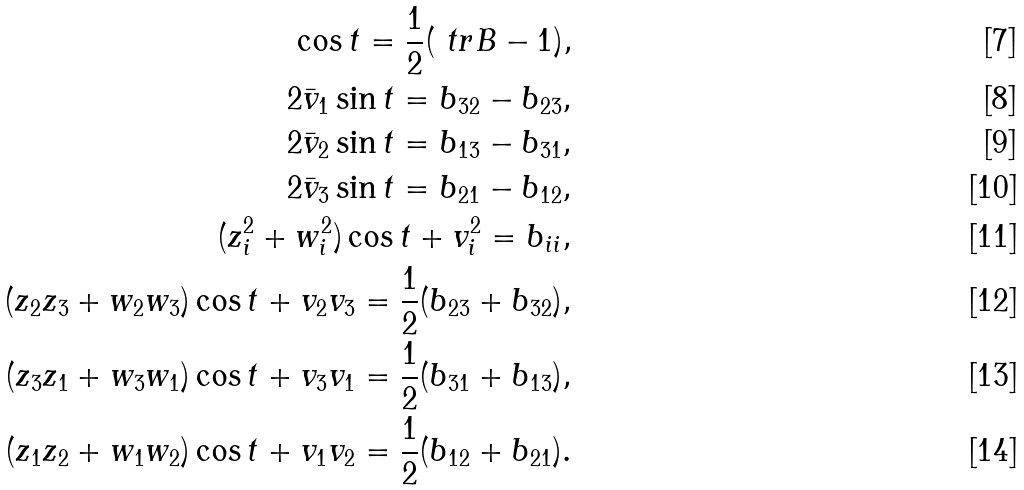<formula> <loc_0><loc_0><loc_500><loc_500>\cos t = \frac { 1 } { 2 } ( \ t r B - 1 ) , \\ 2 \bar { v } _ { 1 } \sin t = b _ { 3 2 } - b _ { 2 3 } , \\ 2 \bar { v } _ { 2 } \sin t = b _ { 1 3 } - b _ { 3 1 } , \\ 2 \bar { v } _ { 3 } \sin t = b _ { 2 1 } - b _ { 1 2 } , \\ ( z _ { i } ^ { 2 } + w _ { i } ^ { 2 } ) \cos t + v _ { i } ^ { 2 } = b _ { i i } , \\ ( z _ { 2 } z _ { 3 } + w _ { 2 } w _ { 3 } ) \cos t + v _ { 2 } v _ { 3 } = \frac { 1 } { 2 } ( b _ { 2 3 } + b _ { 3 2 } ) , \\ ( z _ { 3 } z _ { 1 } + w _ { 3 } w _ { 1 } ) \cos t + v _ { 3 } v _ { 1 } = \frac { 1 } { 2 } ( b _ { 3 1 } + b _ { 1 3 } ) , \\ ( z _ { 1 } z _ { 2 } + w _ { 1 } w _ { 2 } ) \cos t + v _ { 1 } v _ { 2 } = \frac { 1 } { 2 } ( b _ { 1 2 } + b _ { 2 1 } ) .</formula> 